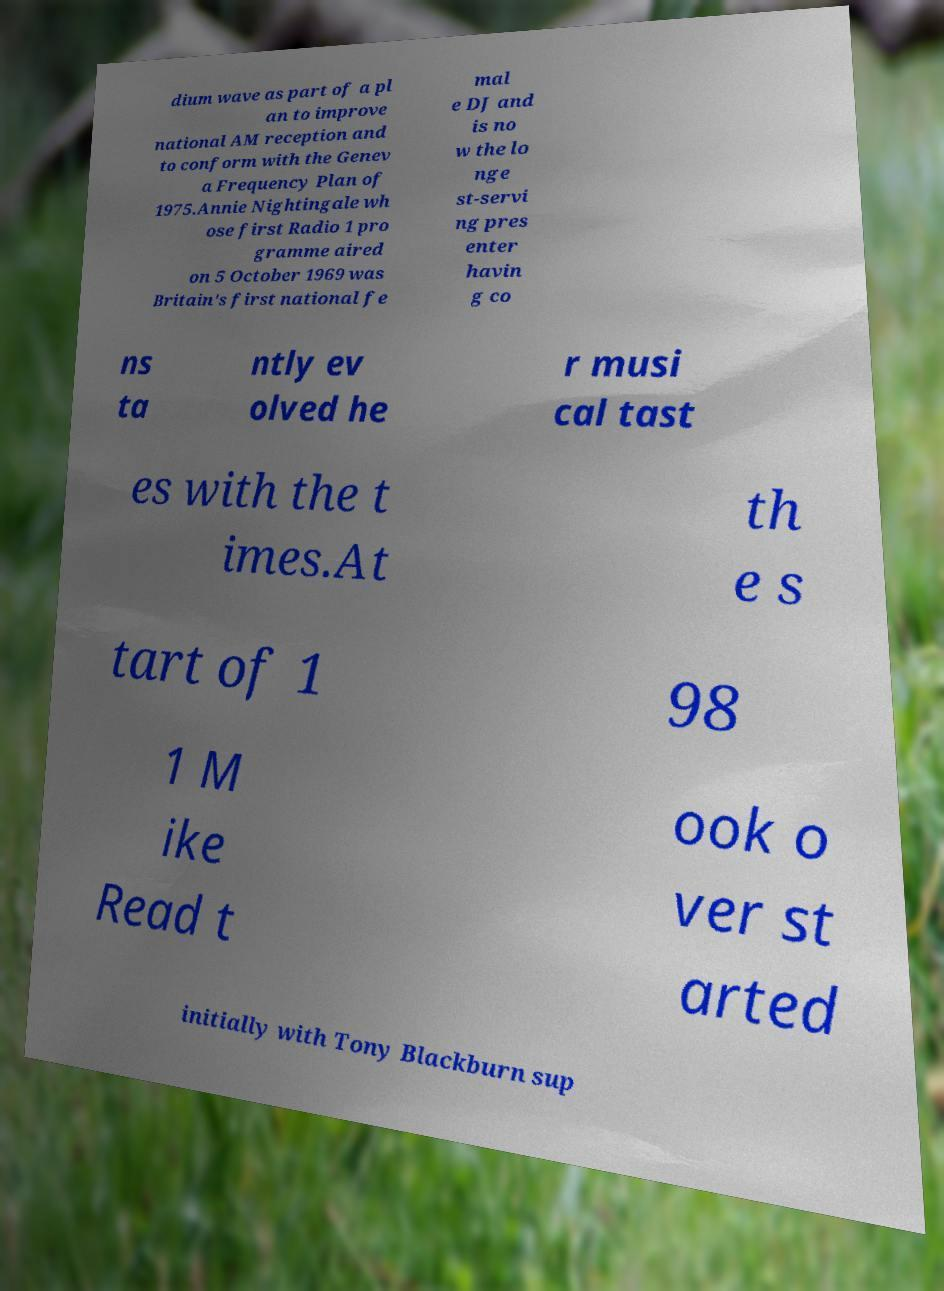Could you extract and type out the text from this image? dium wave as part of a pl an to improve national AM reception and to conform with the Genev a Frequency Plan of 1975.Annie Nightingale wh ose first Radio 1 pro gramme aired on 5 October 1969 was Britain's first national fe mal e DJ and is no w the lo nge st-servi ng pres enter havin g co ns ta ntly ev olved he r musi cal tast es with the t imes.At th e s tart of 1 98 1 M ike Read t ook o ver st arted initially with Tony Blackburn sup 